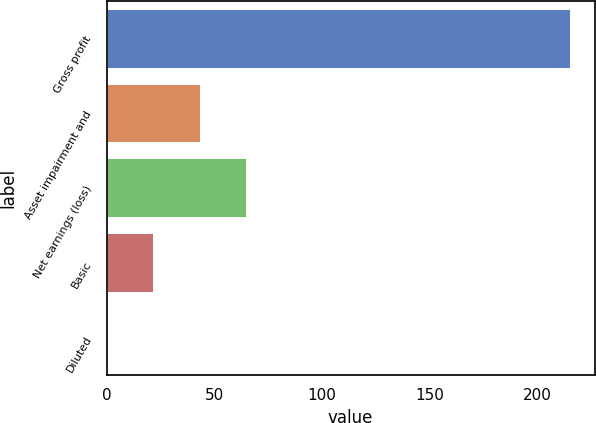Convert chart. <chart><loc_0><loc_0><loc_500><loc_500><bar_chart><fcel>Gross profit<fcel>Asset impairment and<fcel>Net earnings (loss)<fcel>Basic<fcel>Diluted<nl><fcel>216<fcel>43.74<fcel>65.27<fcel>22.21<fcel>0.68<nl></chart> 